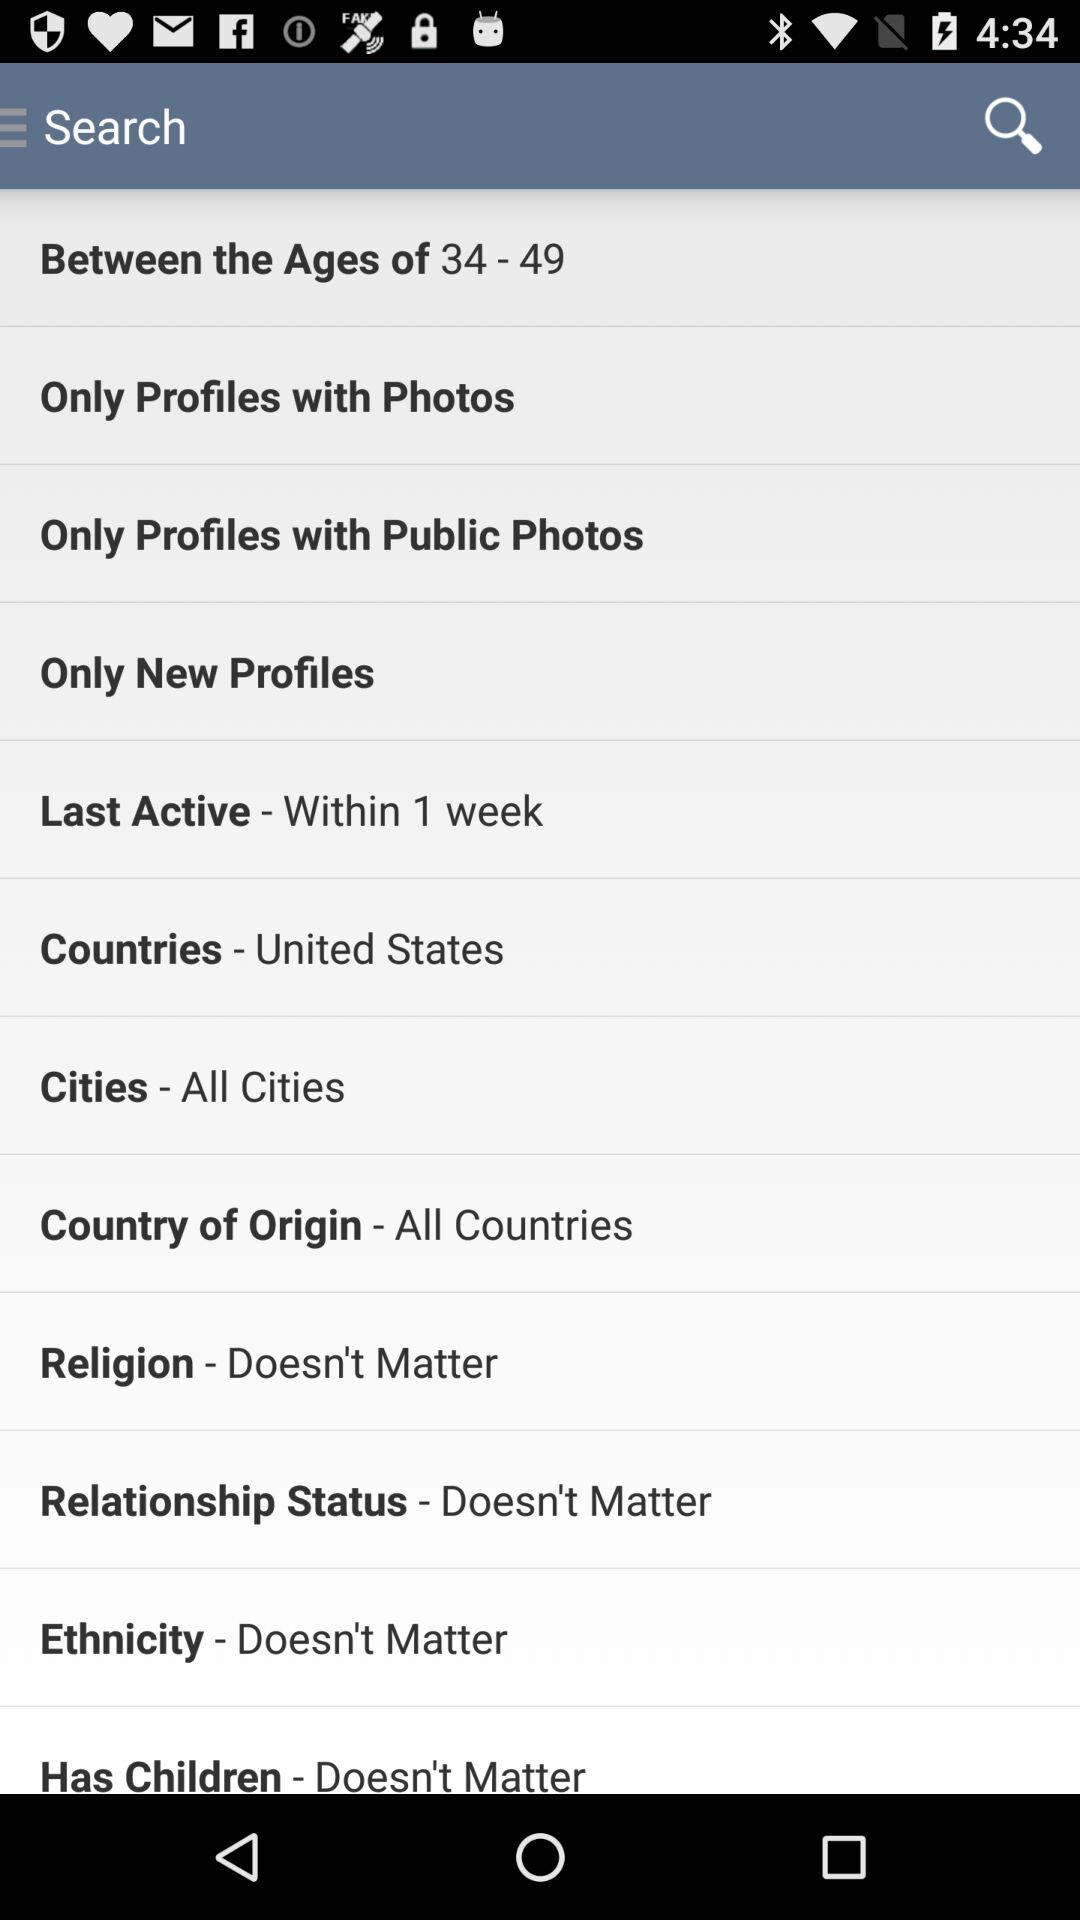What is the selected option in "Last Active"? The selected option is "Within 1 week". 